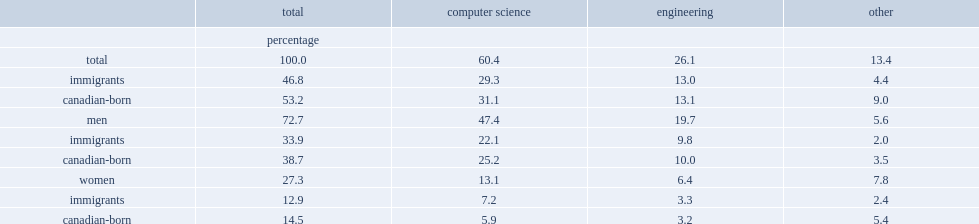By what percentage did immigrant women contribute to the total increase in scientific workers at the university level? 12.9. By what percentage did immigrant women contribute to the total increase in scientific workers at the university level? 14.5. By what percentage did immigrant men contribute to the total increase in scientific workers at the university level? 33.9. By what percentage did canadian-born men contribute to the total increase in scientific workers at the university level? 38.7. 